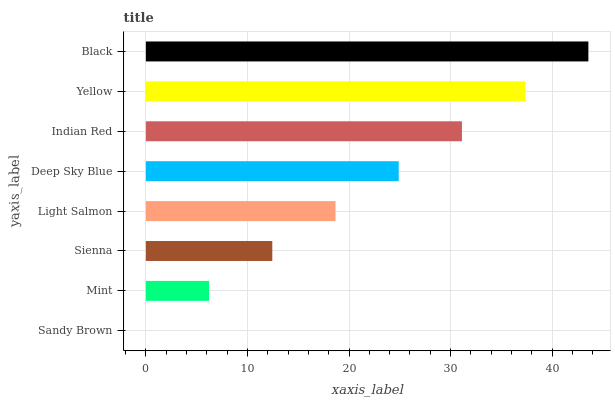Is Sandy Brown the minimum?
Answer yes or no. Yes. Is Black the maximum?
Answer yes or no. Yes. Is Mint the minimum?
Answer yes or no. No. Is Mint the maximum?
Answer yes or no. No. Is Mint greater than Sandy Brown?
Answer yes or no. Yes. Is Sandy Brown less than Mint?
Answer yes or no. Yes. Is Sandy Brown greater than Mint?
Answer yes or no. No. Is Mint less than Sandy Brown?
Answer yes or no. No. Is Deep Sky Blue the high median?
Answer yes or no. Yes. Is Light Salmon the low median?
Answer yes or no. Yes. Is Mint the high median?
Answer yes or no. No. Is Mint the low median?
Answer yes or no. No. 